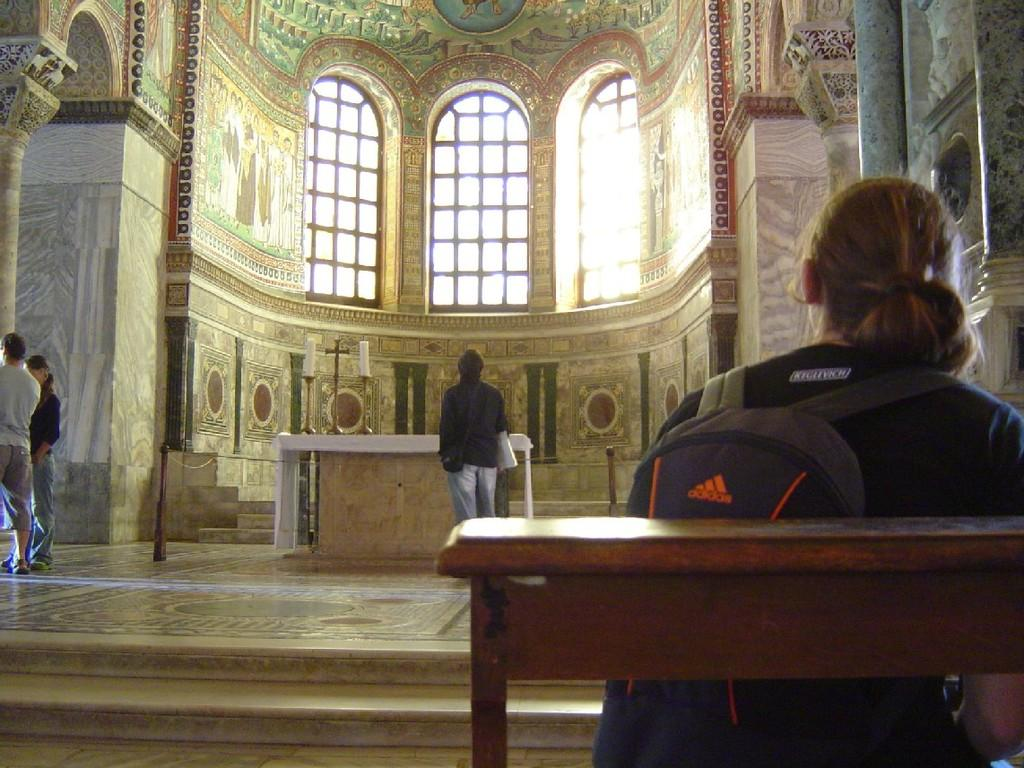What architectural features can be seen in the image? There are windows, walls, and stairs visible in the image. What type of lighting is present in the image? There are candles in the image. Are there any people in the image? Yes, there are people in the image. What type of rake is being used by the laborer in the image? There is no rake or laborer present in the image. How does the pump function in the image? There is no pump present in the image. 